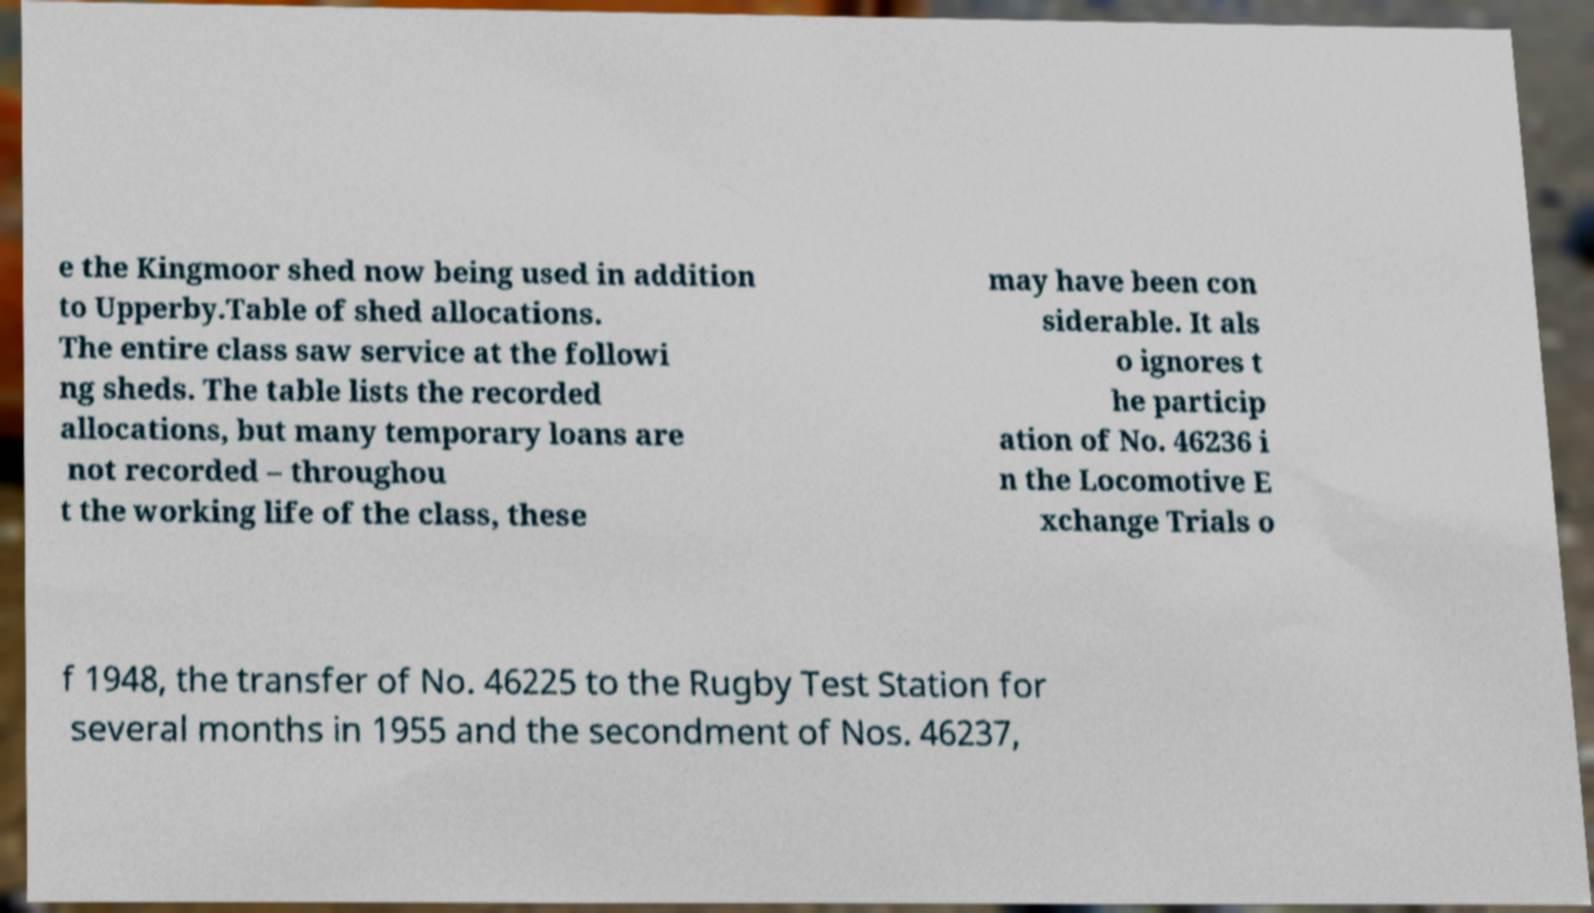Could you assist in decoding the text presented in this image and type it out clearly? e the Kingmoor shed now being used in addition to Upperby.Table of shed allocations. The entire class saw service at the followi ng sheds. The table lists the recorded allocations, but many temporary loans are not recorded – throughou t the working life of the class, these may have been con siderable. It als o ignores t he particip ation of No. 46236 i n the Locomotive E xchange Trials o f 1948, the transfer of No. 46225 to the Rugby Test Station for several months in 1955 and the secondment of Nos. 46237, 